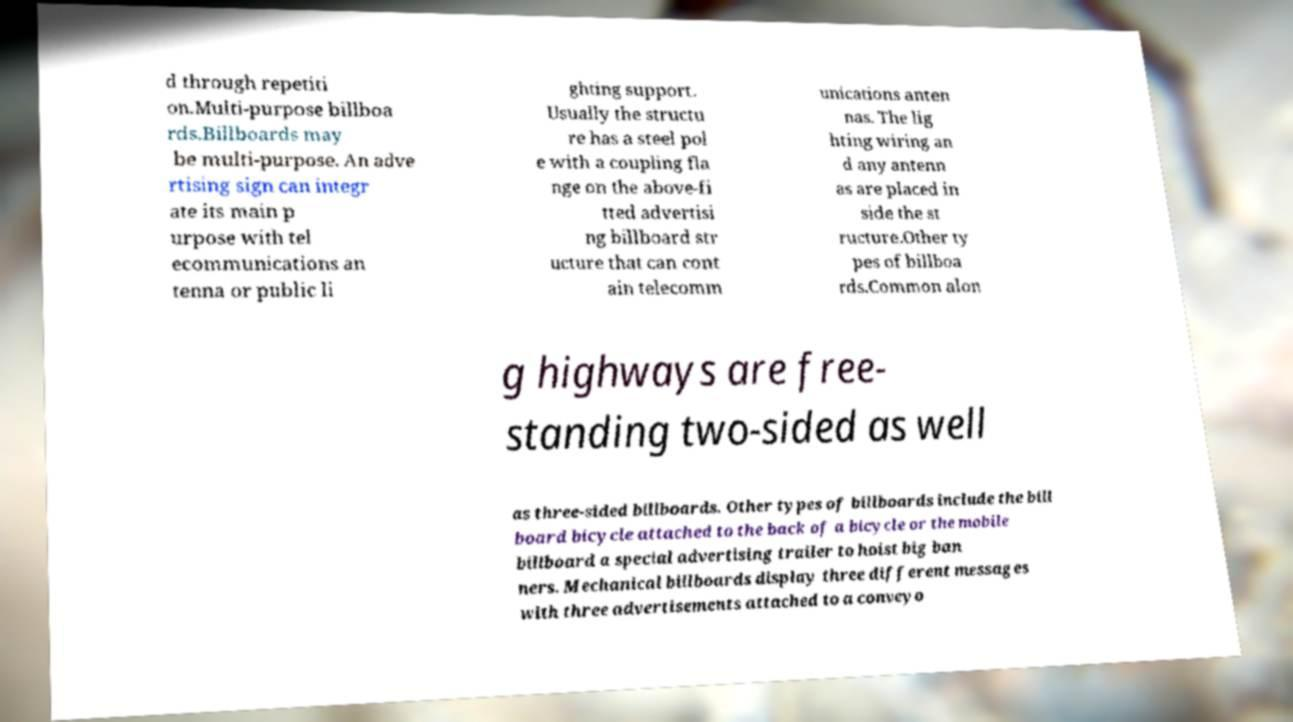Could you assist in decoding the text presented in this image and type it out clearly? d through repetiti on.Multi-purpose billboa rds.Billboards may be multi-purpose. An adve rtising sign can integr ate its main p urpose with tel ecommunications an tenna or public li ghting support. Usually the structu re has a steel pol e with a coupling fla nge on the above-fi tted advertisi ng billboard str ucture that can cont ain telecomm unications anten nas. The lig hting wiring an d any antenn as are placed in side the st ructure.Other ty pes of billboa rds.Common alon g highways are free- standing two-sided as well as three-sided billboards. Other types of billboards include the bill board bicycle attached to the back of a bicycle or the mobile billboard a special advertising trailer to hoist big ban ners. Mechanical billboards display three different messages with three advertisements attached to a conveyo 